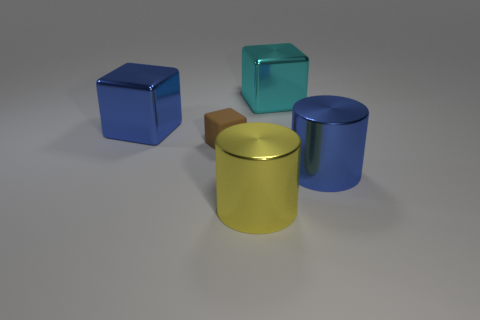Subtract all shiny blocks. How many blocks are left? 1 Subtract all brown blocks. How many blocks are left? 2 Add 4 small yellow things. How many objects exist? 9 Subtract 3 blocks. How many blocks are left? 0 Subtract all blue blocks. How many cyan cylinders are left? 0 Subtract all cylinders. How many objects are left? 3 Subtract all brown cylinders. Subtract all green cubes. How many cylinders are left? 2 Add 2 yellow cylinders. How many yellow cylinders exist? 3 Subtract 0 purple cubes. How many objects are left? 5 Subtract all large shiny things. Subtract all cyan metallic things. How many objects are left? 0 